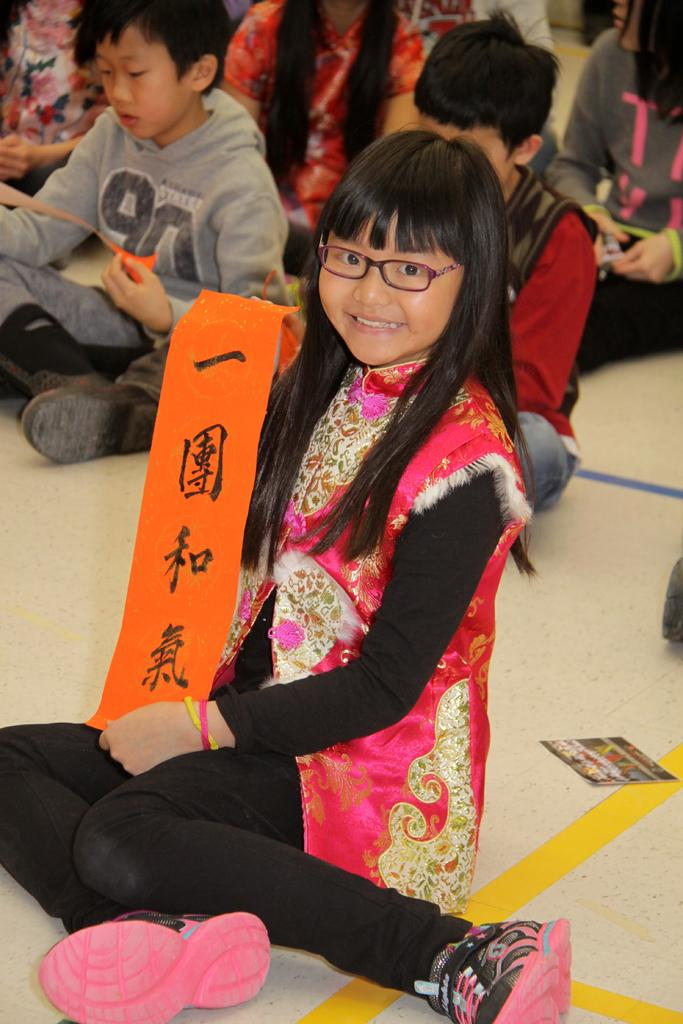Who is the main subject in the foreground of the picture? There is a girl in the foreground of the picture. What is the girl holding in her hand? The girl is holding a red ribbon. What can be seen in the background of the picture? There are kids sitting in the background of the picture. Where is the photograph located in the image? The photograph is on the right side of the image. What type of alley can be seen in the background of the image? There is no alley present in the image; it features a girl holding a red ribbon, kids sitting in the background, and a photograph on the right side. 